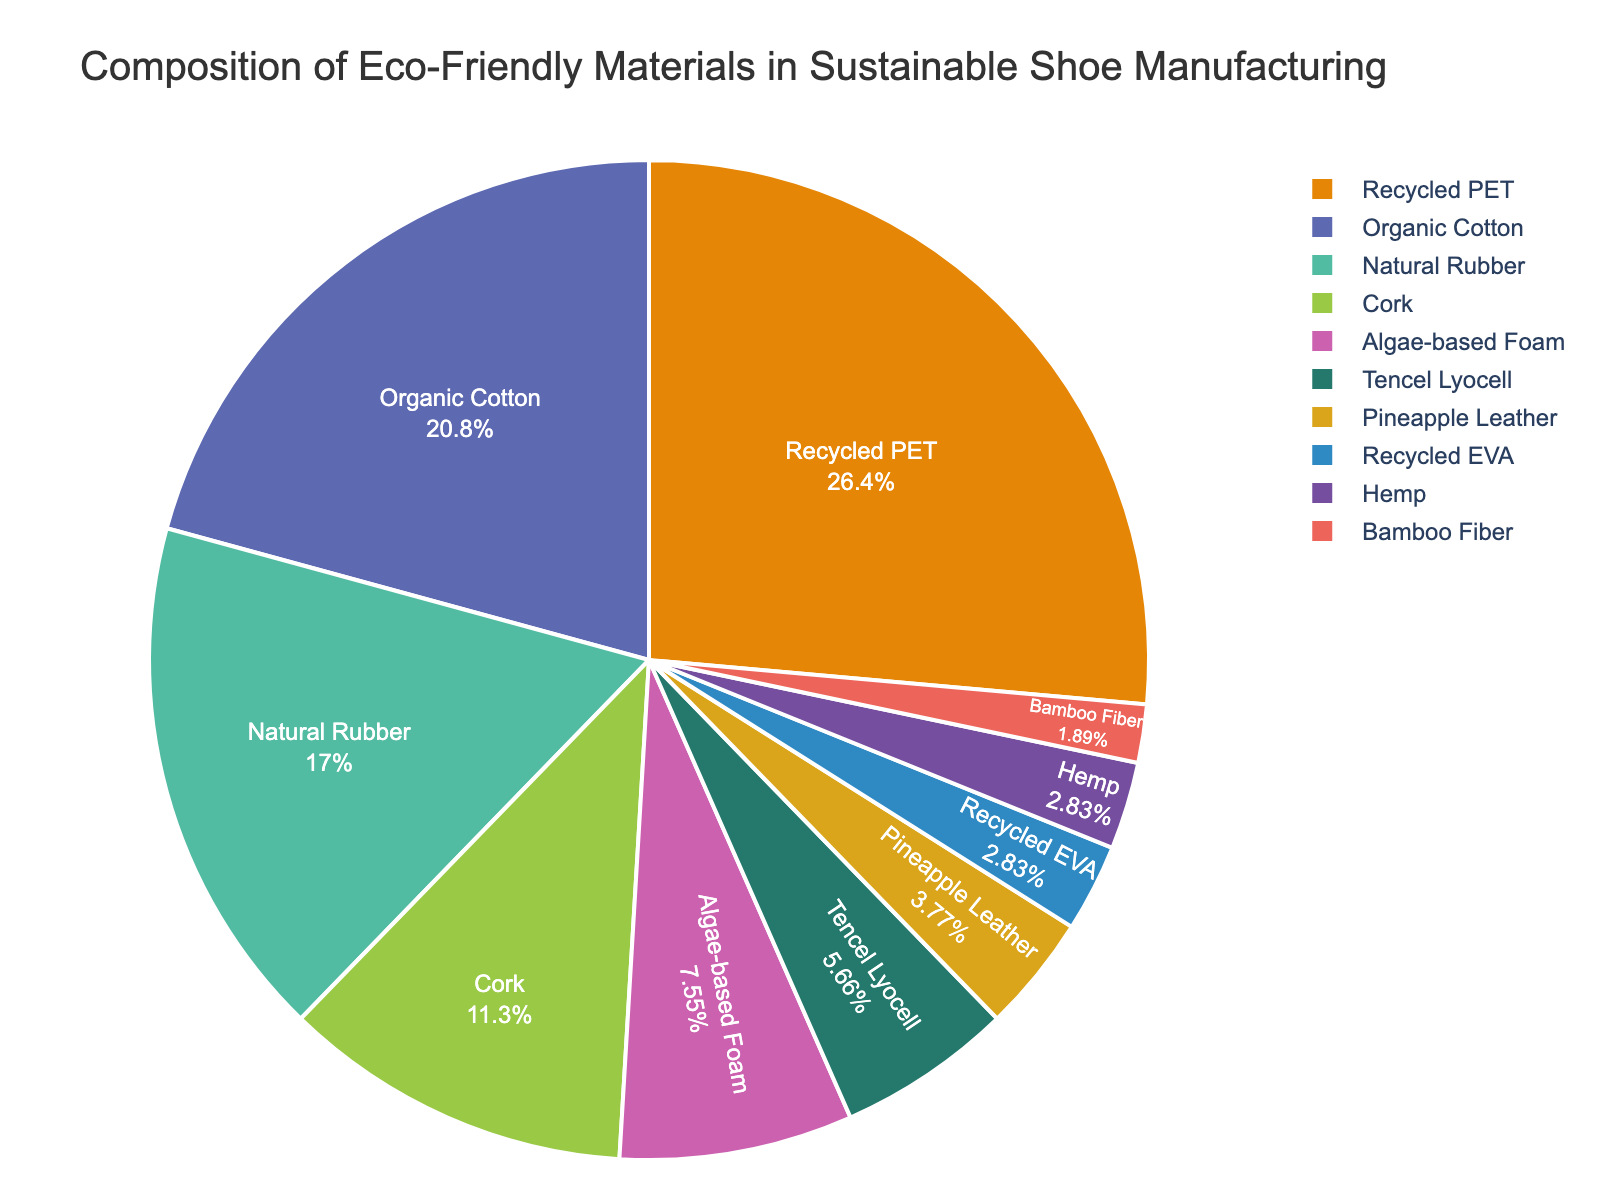what is the total percentage of materials made from plant-based resources? Add the percentages of Organic Cotton (22%), Natural Rubber (18%), Cork (12%), Pineapple Leather (4%), Hemp (3%), and Bamboo Fiber (2%) to get the total percentage: 22 + 18 + 12 + 4 + 3 + 2 = 61%
Answer: 61% Which material has the highest percentage, and how much higher is it compared to Tencel Lyocell? Recycled PET has the highest percentage at 28%. Tencel Lyocell is at 6%. The difference is 28 - 6 = 22%.
Answer: Recycled PET; 22% Which two materials have the closest percentages, and what are their values? Natural Rubber (18%) and Cork (12%) have the closest percentages, and their values are 18% and 12%, respectively.
Answer: Natural Rubber and Cork; 18% and 12% What is the average percentage of the materials in the figure? Sum the percentages of all materials and divide by the number of materials: (28 + 22 + 18 + 12 + 8 + 6 + 4 + 3 + 3 + 2) / 10 = 106 / 10 = 10.6%
Answer: 10.6% Which material contributes the least to the total composition, and how does its percentage compare to Bamboo Fiber? Bamboo Fiber contributes the least at 2%. Recycled EVA and Hemp each contribute 3%, which is 1% more than Bamboo Fiber.
Answer: Bamboo Fiber; 1% more What is the combined percentage of all materials except Recycled PET and Organic Cotton? Sum the percentages of all materials except Recycled PET and Organic Cotton: 18 + 12 + 8 + 6 + 4 + 3 + 3 + 2 = 56%
Answer: 56% What is the difference in percentage between Algae-based Foam and Recycled PET? Subtract the percentage of Algae-based Foam from Recycled PET: 28 - 8 = 20%
Answer: 20% If you combine Natural Rubber and Cork, does their percentage exceed Organic Cotton's percentage? Sum the percentages of Natural Rubber and Cork (18 + 12 = 30%) and compare to Organic Cotton's percentage, which is 22%. Yes, 30% exceeds 22%.
Answer: Yes; 30% vs 22% Which materials have less than 5% contribution, and what are their combined percentages? Pineapple Leather (4%), Recycled EVA (3%), Hemp (3%), and Bamboo Fiber (2%) have less than 5%. Their combined percentages are 4 + 3 + 3 + 2 = 12%.
Answer: Pineapple Leather, Recycled EVA, Hemp, Bamboo Fiber; 12% What is the ratio of the percentage of Natural Rubber to that of Tencel Lyocell? The percentages of Natural Rubber and Tencel Lyocell are 18% and 6%, respectively. The ratio is 18:6, which simplifies to 3:1.
Answer: 3:1 